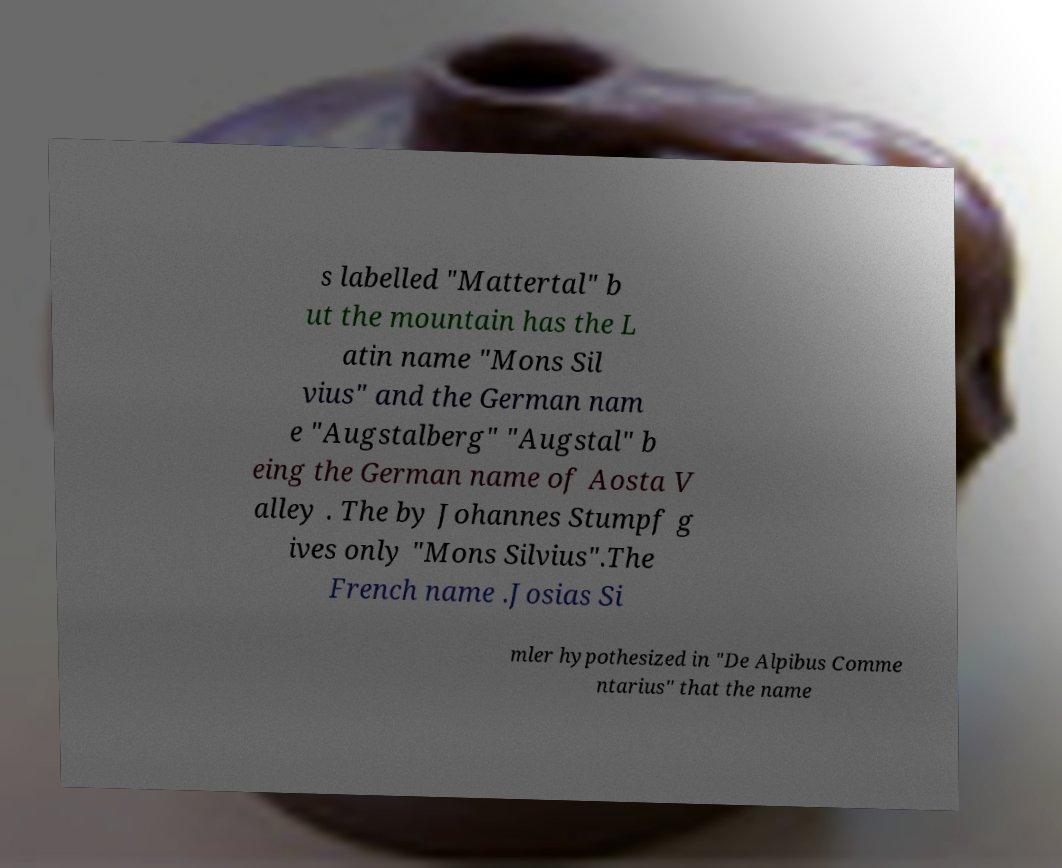There's text embedded in this image that I need extracted. Can you transcribe it verbatim? s labelled "Mattertal" b ut the mountain has the L atin name "Mons Sil vius" and the German nam e "Augstalberg" "Augstal" b eing the German name of Aosta V alley . The by Johannes Stumpf g ives only "Mons Silvius".The French name .Josias Si mler hypothesized in "De Alpibus Comme ntarius" that the name 